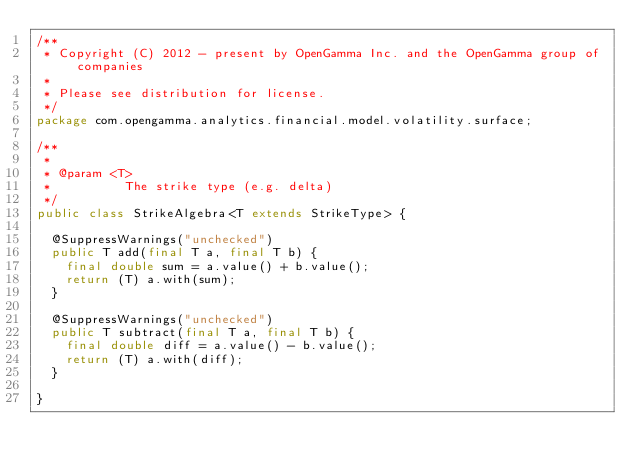<code> <loc_0><loc_0><loc_500><loc_500><_Java_>/**
 * Copyright (C) 2012 - present by OpenGamma Inc. and the OpenGamma group of companies
 *
 * Please see distribution for license.
 */
package com.opengamma.analytics.financial.model.volatility.surface;

/**
 *
 * @param <T>
 *          The strike type (e.g. delta)
 */
public class StrikeAlgebra<T extends StrikeType> {

  @SuppressWarnings("unchecked")
  public T add(final T a, final T b) {
    final double sum = a.value() + b.value();
    return (T) a.with(sum);
  }

  @SuppressWarnings("unchecked")
  public T subtract(final T a, final T b) {
    final double diff = a.value() - b.value();
    return (T) a.with(diff);
  }

}
</code> 